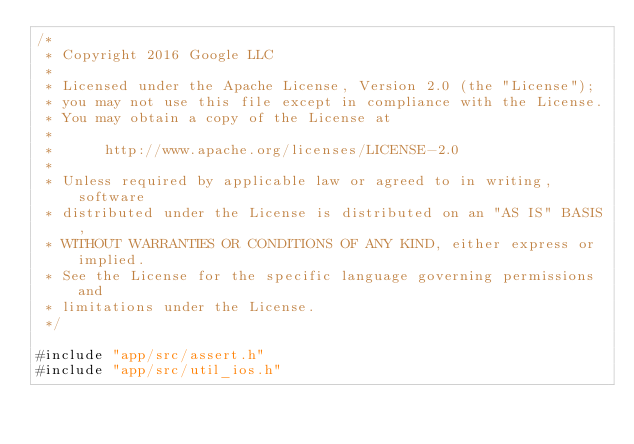Convert code to text. <code><loc_0><loc_0><loc_500><loc_500><_ObjectiveC_>/*
 * Copyright 2016 Google LLC
 *
 * Licensed under the Apache License, Version 2.0 (the "License");
 * you may not use this file except in compliance with the License.
 * You may obtain a copy of the License at
 *
 *      http://www.apache.org/licenses/LICENSE-2.0
 *
 * Unless required by applicable law or agreed to in writing, software
 * distributed under the License is distributed on an "AS IS" BASIS,
 * WITHOUT WARRANTIES OR CONDITIONS OF ANY KIND, either express or implied.
 * See the License for the specific language governing permissions and
 * limitations under the License.
 */

#include "app/src/assert.h"
#include "app/src/util_ios.h"</code> 